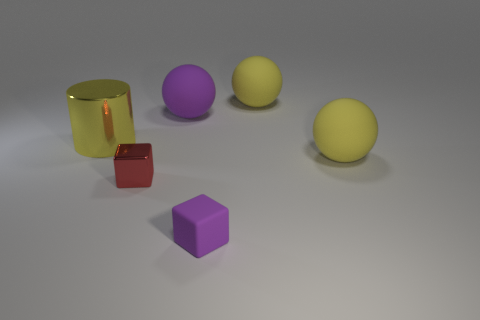What number of things are yellow rubber things that are in front of the large yellow metal cylinder or things to the left of the small matte block?
Give a very brief answer. 4. Do the metal cylinder and the rubber cube have the same color?
Your response must be concise. No. Is the number of big shiny objects less than the number of yellow shiny cubes?
Your answer should be very brief. No. Are there any metallic blocks to the left of the small red shiny block?
Offer a terse response. No. Is the red block made of the same material as the cylinder?
Your response must be concise. Yes. There is a tiny shiny object that is the same shape as the tiny purple matte thing; what color is it?
Your answer should be very brief. Red. There is a big matte ball that is left of the rubber block; does it have the same color as the large metallic thing?
Offer a terse response. No. The other matte object that is the same color as the small rubber thing is what shape?
Your response must be concise. Sphere. How many other cylinders are made of the same material as the large cylinder?
Offer a terse response. 0. How many large purple matte spheres are behind the red object?
Provide a succinct answer. 1. 